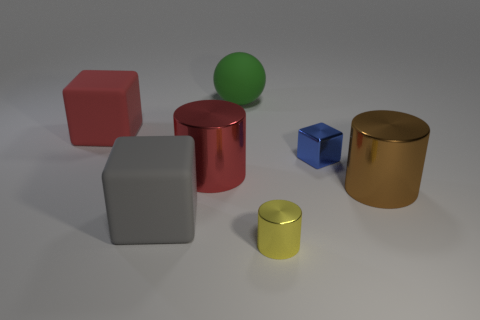Add 1 brown shiny cylinders. How many objects exist? 8 Subtract all blue metallic cubes. How many cubes are left? 2 Subtract 1 cylinders. How many cylinders are left? 2 Subtract all cylinders. How many objects are left? 4 Add 2 big rubber blocks. How many big rubber blocks exist? 4 Subtract 0 cyan blocks. How many objects are left? 7 Subtract all red metal cylinders. Subtract all big rubber things. How many objects are left? 3 Add 3 gray blocks. How many gray blocks are left? 4 